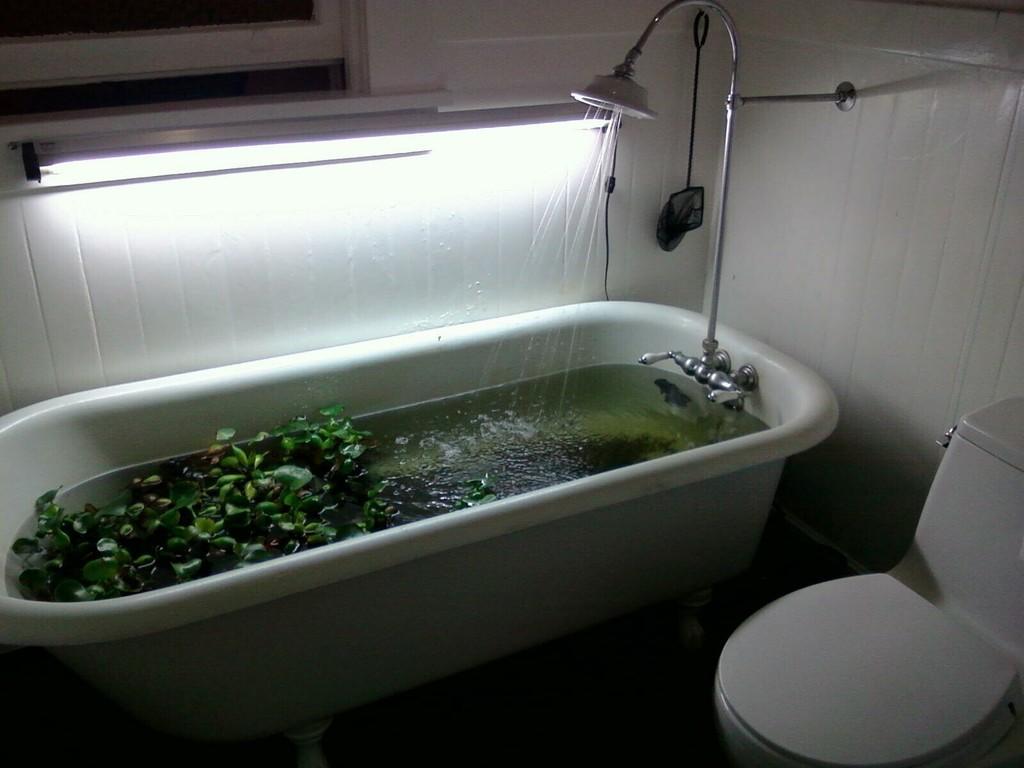Describe this image in one or two sentences. In the image we can see bathtub, in it there are leaves and water. Here we can see shower, light and western toilet. 